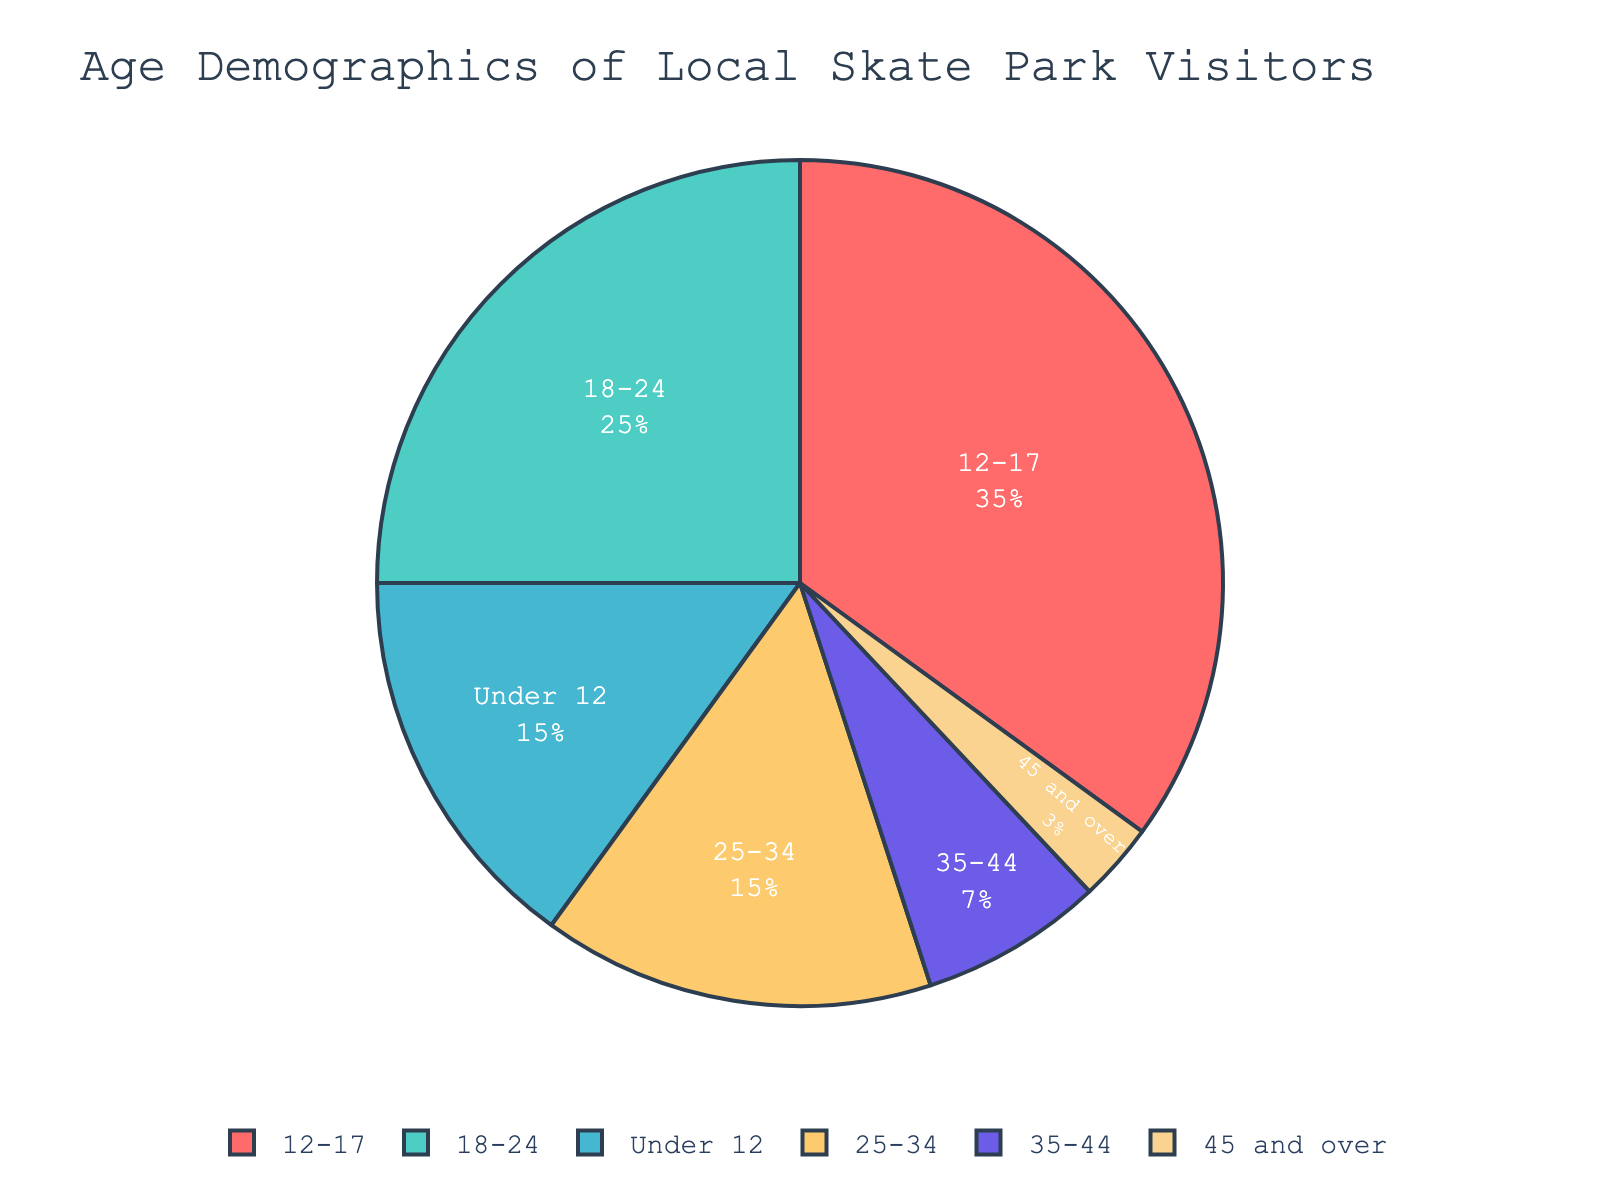What's the largest age group of visitors at the skate park? According to the pie chart, the largest age group is represented by the segment that occupies the largest portion of the chart. This is the 12-17 age group.
Answer: 12-17 What's the difference between the percentages of visitors aged 18-24 and those aged 25-34? The chart shows that the percentage of visitors aged 18-24 is 25%, and the percentage of visitors aged 25-34 is 15%. The difference is 25% - 15%.
Answer: 10% How much larger is the percentage of visitors under 18 compared to those aged 35 and above combined? Sum the percentages of the age groups under 18: 15% + 35% = 50%. Then sum the percentages of age groups 35-44 and 45 and over: 7% + 3% = 10%. Now, subtract the latter sum from the former: 50% - 10%.
Answer: 40% Which age group has the smallest percentage of visitors? The segment with the smallest visible portion on the pie chart represents the 45 and over age group, which is 3%.
Answer: 45 and over What is the total percentage of visitors aged 25 and older? Add together the percentages of all age groups starting from 25-34: 15% + 7% + 3%.
Answer: 25% Which age group's segment appears in blue on the pie chart? By identifying the segments by color, the blue segment represents the 18-24 age group.
Answer: 18-24 Is the number of visitors aged 12-17 greater than the combined number of visitors under 12 and 25-34? Compare the percentage of the 12-17 age group (35%) with the combined percentages of the under 12 (15%) and the 25-34 (15%) age groups: 35% vs. 15% + 15% = 30%.
Answer: Yes What percentage of visitors are either under 12 or over 44 years old? Sum the percentages of the under 12 age group and the 45 and over age group: 15% + 3%.
Answer: 18% How do the visitors aged 18-24 compare in proportion to those aged 35-44? The 18-24 age group has 25%, and the 35-44 age group has 7%. By comparing these two, 25% is significantly larger than 7%.
Answer: Significantly larger What's the combined percentage of visitors aged 12-17 and 18-24? Add the percentages of the 12-17 and 18-24 age groups together: 35% + 25%.
Answer: 60% 